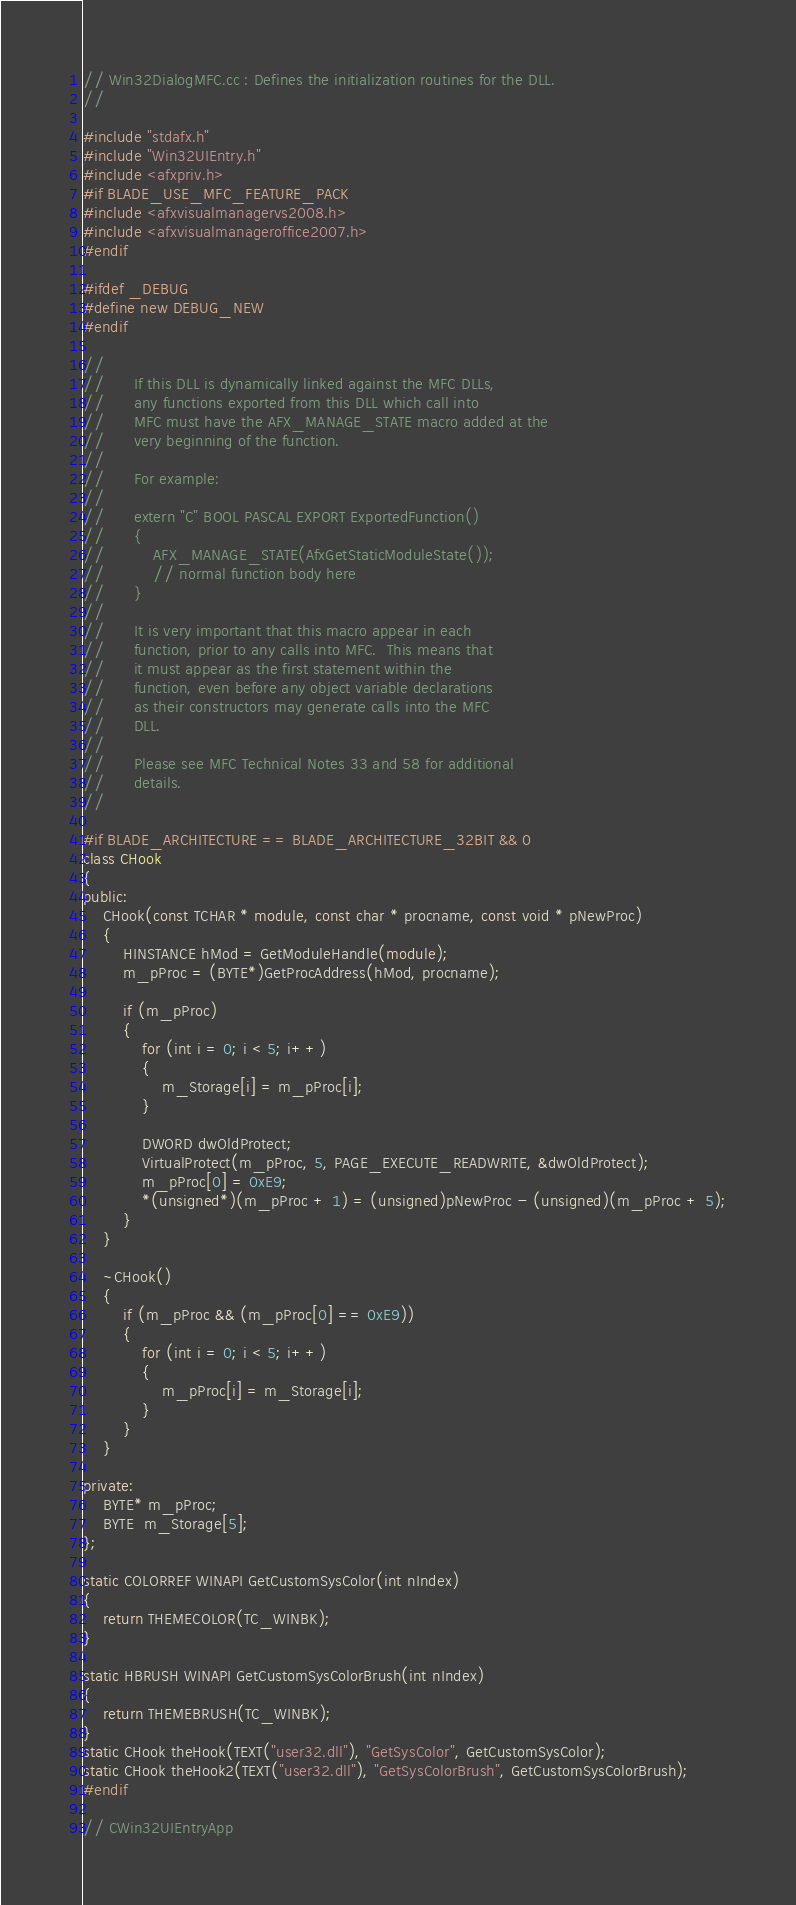<code> <loc_0><loc_0><loc_500><loc_500><_C++_>// Win32DialogMFC.cc : Defines the initialization routines for the DLL.
//

#include "stdafx.h"
#include "Win32UIEntry.h"
#include <afxpriv.h>
#if BLADE_USE_MFC_FEATURE_PACK
#include <afxvisualmanagervs2008.h>
#include <afxvisualmanageroffice2007.h>
#endif

#ifdef _DEBUG
#define new DEBUG_NEW
#endif

//
//		If this DLL is dynamically linked against the MFC DLLs,
//		any functions exported from this DLL which call into
//		MFC must have the AFX_MANAGE_STATE macro added at the
//		very beginning of the function.
//
//		For example:
//
//		extern "C" BOOL PASCAL EXPORT ExportedFunction()
//		{
//			AFX_MANAGE_STATE(AfxGetStaticModuleState());
//			// normal function body here
//		}
//
//		It is very important that this macro appear in each
//		function, prior to any calls into MFC.  This means that
//		it must appear as the first statement within the 
//		function, even before any object variable declarations
//		as their constructors may generate calls into the MFC
//		DLL.
//
//		Please see MFC Technical Notes 33 and 58 for additional
//		details.
//

#if BLADE_ARCHITECTURE == BLADE_ARCHITECTURE_32BIT && 0
class CHook
{
public:
	CHook(const TCHAR * module, const char * procname, const void * pNewProc)
	{
		HINSTANCE hMod = GetModuleHandle(module);
		m_pProc = (BYTE*)GetProcAddress(hMod, procname);

		if (m_pProc)
		{
			for (int i = 0; i < 5; i++)
			{
				m_Storage[i] = m_pProc[i];
			}

			DWORD dwOldProtect;
			VirtualProtect(m_pProc, 5, PAGE_EXECUTE_READWRITE, &dwOldProtect);
			m_pProc[0] = 0xE9;
			*(unsigned*)(m_pProc + 1) = (unsigned)pNewProc - (unsigned)(m_pProc + 5);
		}
	}

	~CHook()
	{
		if (m_pProc && (m_pProc[0] == 0xE9))
		{
			for (int i = 0; i < 5; i++)
			{
				m_pProc[i] = m_Storage[i];
			}
		}
	}

private:
	BYTE* m_pProc;
	BYTE  m_Storage[5];
};

static COLORREF WINAPI GetCustomSysColor(int nIndex)
{
	return THEMECOLOR(TC_WINBK);
}

static HBRUSH WINAPI GetCustomSysColorBrush(int nIndex)
{
	return THEMEBRUSH(TC_WINBK);
}
static CHook theHook(TEXT("user32.dll"), "GetSysColor", GetCustomSysColor);
static CHook theHook2(TEXT("user32.dll"), "GetSysColorBrush", GetCustomSysColorBrush);
#endif

// CWin32UIEntryApp
</code> 